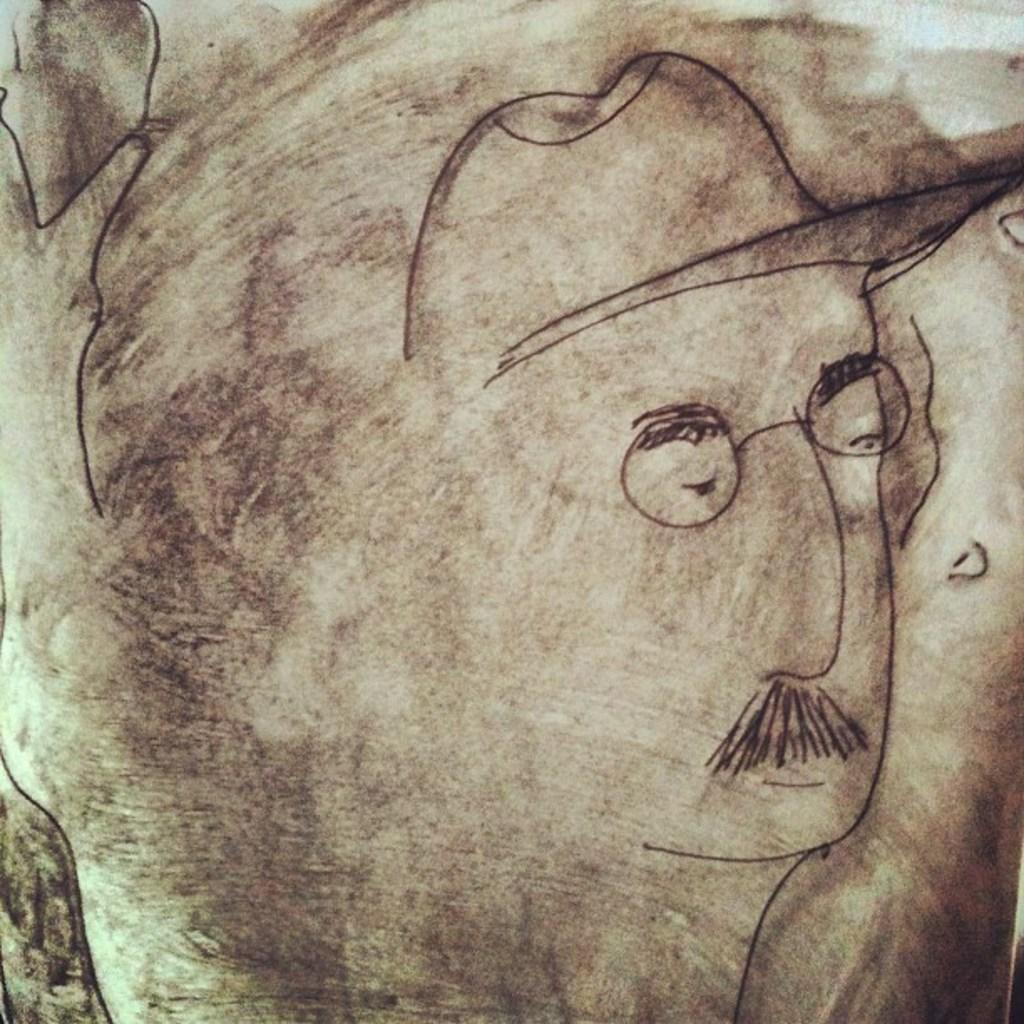What is the main subject of the image? The main subject of the image is a sketch of a person. What colors are used in the sketch? The sketch uses brown, black, and white colors. Who is delivering the parcel to the person in the sketch? There is no parcel or person delivering it in the image; it is a sketch of a person with no additional context. 